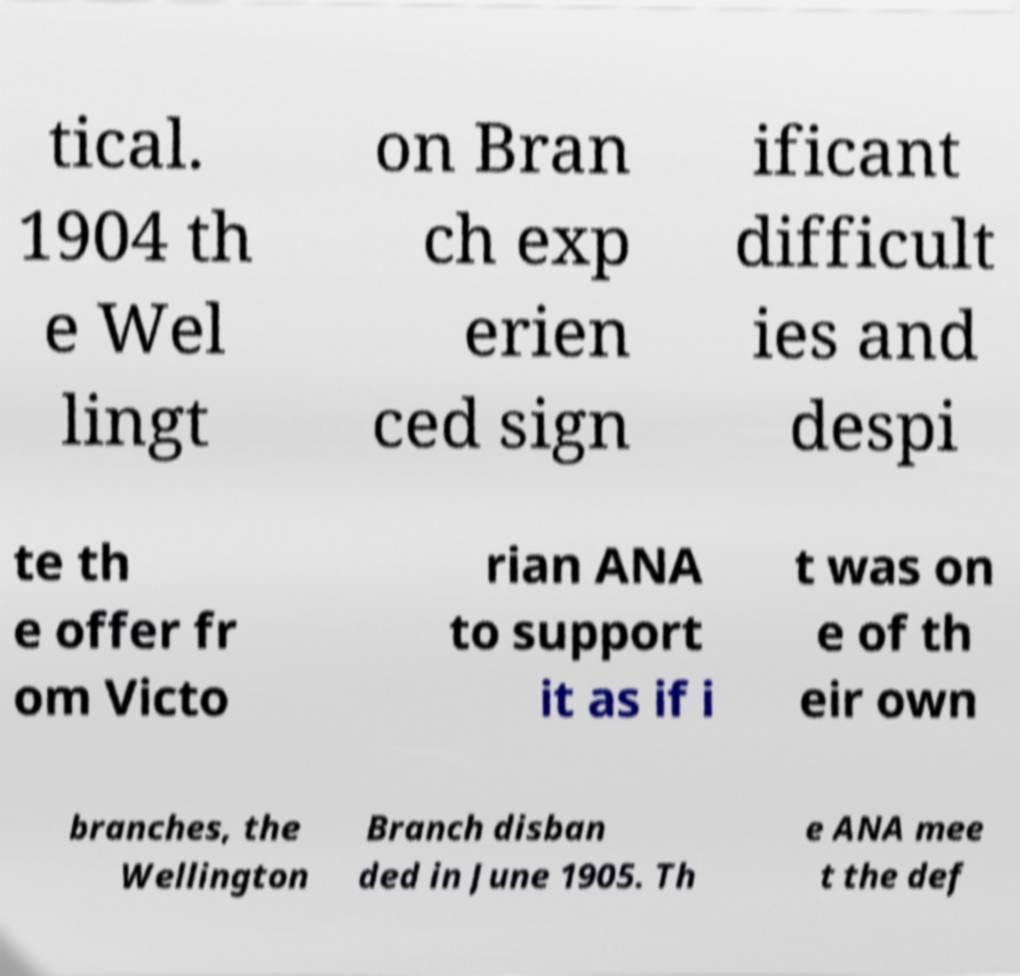I need the written content from this picture converted into text. Can you do that? tical. 1904 th e Wel lingt on Bran ch exp erien ced sign ificant difficult ies and despi te th e offer fr om Victo rian ANA to support it as if i t was on e of th eir own branches, the Wellington Branch disban ded in June 1905. Th e ANA mee t the def 